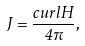<formula> <loc_0><loc_0><loc_500><loc_500>J = \frac { c u r l H } { 4 \pi } ,</formula> 